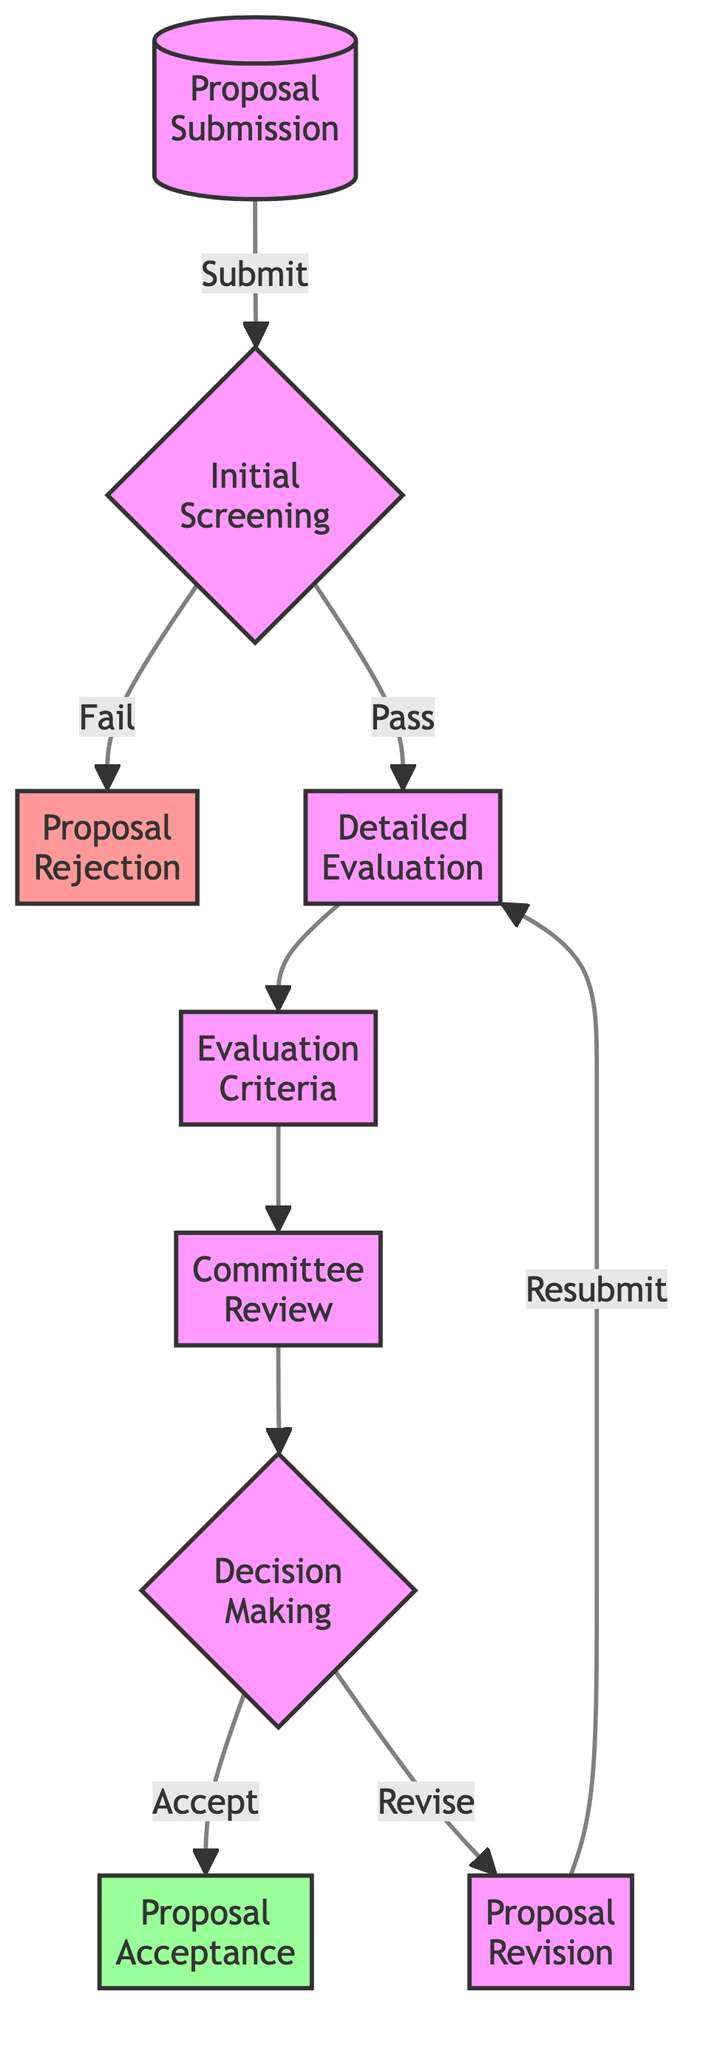What is the first step in the proposal evaluation process? The first step in the process is "Proposal Submission," where students submit their research proposals.
Answer: Proposal Submission How many nodes are there in the flow chart? By counting all the distinct steps from the start to the end, there are a total of nine nodes in the flow chart.
Answer: 9 What happens after "Initial Screening" if a proposal passes? If a proposal passes the "Initial Screening," the next step is "Detailed Evaluation," where the proposal undergoes a more thorough review.
Answer: Detailed Evaluation What are the two possible outcomes after the "Decision Making" step? The two outcomes after "Decision Making" are "Proposal Acceptance" and "Proposal Revision," depending on the committee's input.
Answer: Proposal Acceptance and Proposal Revision Which node is classified as rejected in the diagram? The node classified as rejected in the diagram is "Proposal Rejection," indicating that proposals failing the initial criteria are rejected.
Answer: Proposal Rejection If a proposal needs revision, what is the next step recommended? If a proposal requires revision, it is sent back to students for specific feedback and the next step is "Proposal Revision," which leads them back to "Detailed Evaluation" after corrections.
Answer: Proposal Revision How many different evaluation criteria are mentioned in the "Evaluation Criteria" node? The "Evaluation Criteria" node mentions five distinct criteria including relevance to the field, innovation, methodology, feasibility, and alignment with student interests.
Answer: 5 If a proposal is accepted, what information is provided to students? When a proposal is accepted, students are announced of the acceptance and provided with guidelines for the next steps.
Answer: Guidelines for the next steps What is the purpose of the "Committee Review" step? The purpose of the "Committee Review" step is for a committee of faculty members to review the proposals and provide their input on each submission.
Answer: Review proposals and provide input 